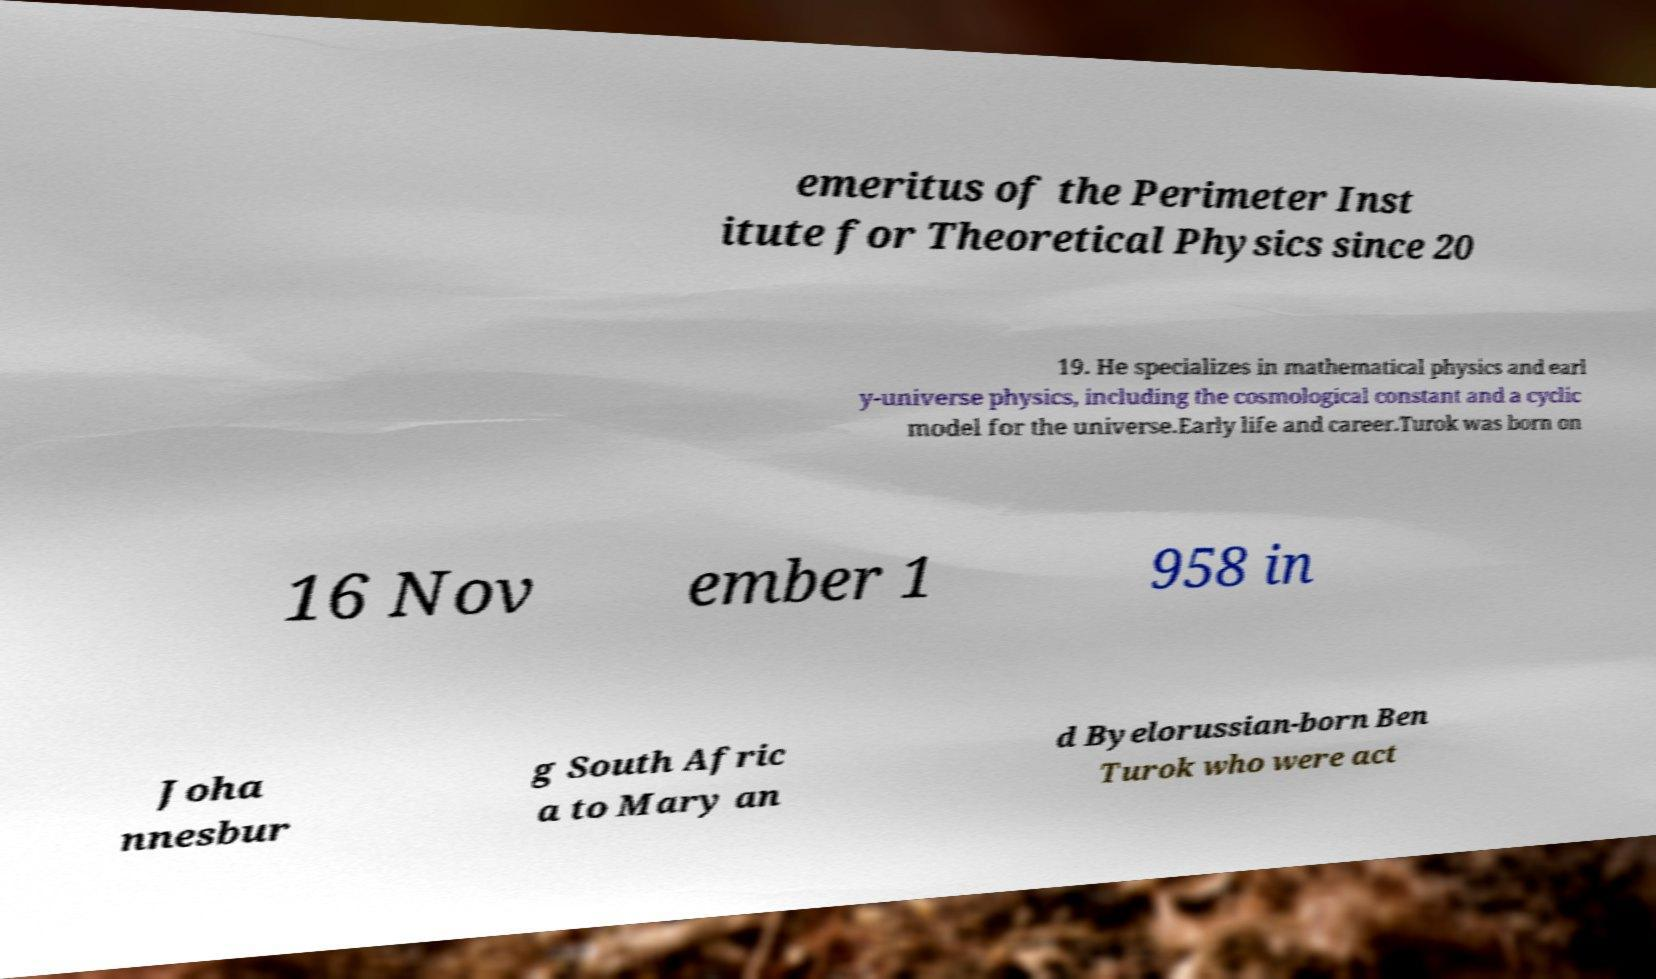Can you read and provide the text displayed in the image?This photo seems to have some interesting text. Can you extract and type it out for me? emeritus of the Perimeter Inst itute for Theoretical Physics since 20 19. He specializes in mathematical physics and earl y-universe physics, including the cosmological constant and a cyclic model for the universe.Early life and career.Turok was born on 16 Nov ember 1 958 in Joha nnesbur g South Afric a to Mary an d Byelorussian-born Ben Turok who were act 